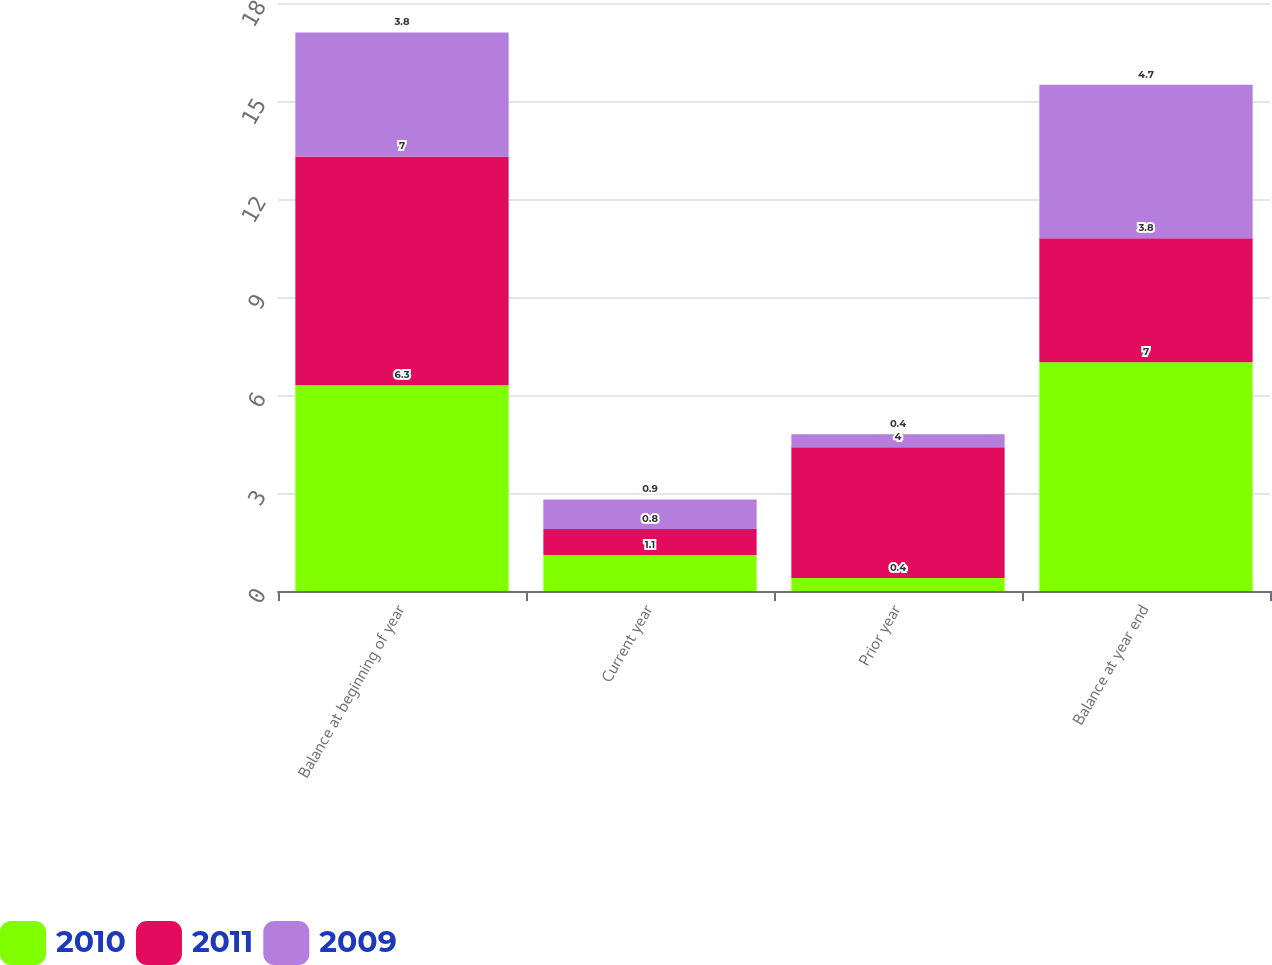Convert chart to OTSL. <chart><loc_0><loc_0><loc_500><loc_500><stacked_bar_chart><ecel><fcel>Balance at beginning of year<fcel>Current year<fcel>Prior year<fcel>Balance at year end<nl><fcel>2010<fcel>6.3<fcel>1.1<fcel>0.4<fcel>7<nl><fcel>2011<fcel>7<fcel>0.8<fcel>4<fcel>3.8<nl><fcel>2009<fcel>3.8<fcel>0.9<fcel>0.4<fcel>4.7<nl></chart> 